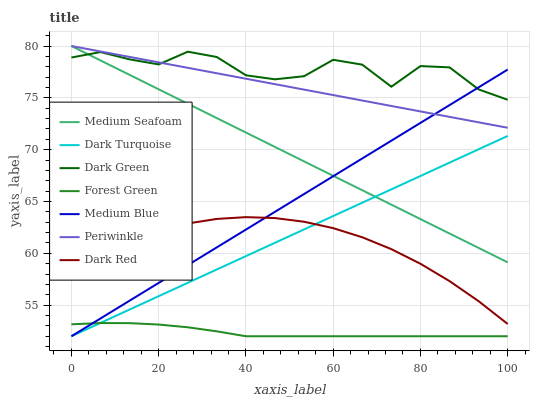Does Forest Green have the minimum area under the curve?
Answer yes or no. Yes. Does Dark Green have the maximum area under the curve?
Answer yes or no. Yes. Does Medium Blue have the minimum area under the curve?
Answer yes or no. No. Does Medium Blue have the maximum area under the curve?
Answer yes or no. No. Is Medium Seafoam the smoothest?
Answer yes or no. Yes. Is Dark Green the roughest?
Answer yes or no. Yes. Is Medium Blue the smoothest?
Answer yes or no. No. Is Medium Blue the roughest?
Answer yes or no. No. Does Dark Turquoise have the lowest value?
Answer yes or no. Yes. Does Periwinkle have the lowest value?
Answer yes or no. No. Does Medium Seafoam have the highest value?
Answer yes or no. Yes. Does Medium Blue have the highest value?
Answer yes or no. No. Is Dark Red less than Periwinkle?
Answer yes or no. Yes. Is Medium Seafoam greater than Dark Red?
Answer yes or no. Yes. Does Medium Blue intersect Forest Green?
Answer yes or no. Yes. Is Medium Blue less than Forest Green?
Answer yes or no. No. Is Medium Blue greater than Forest Green?
Answer yes or no. No. Does Dark Red intersect Periwinkle?
Answer yes or no. No. 